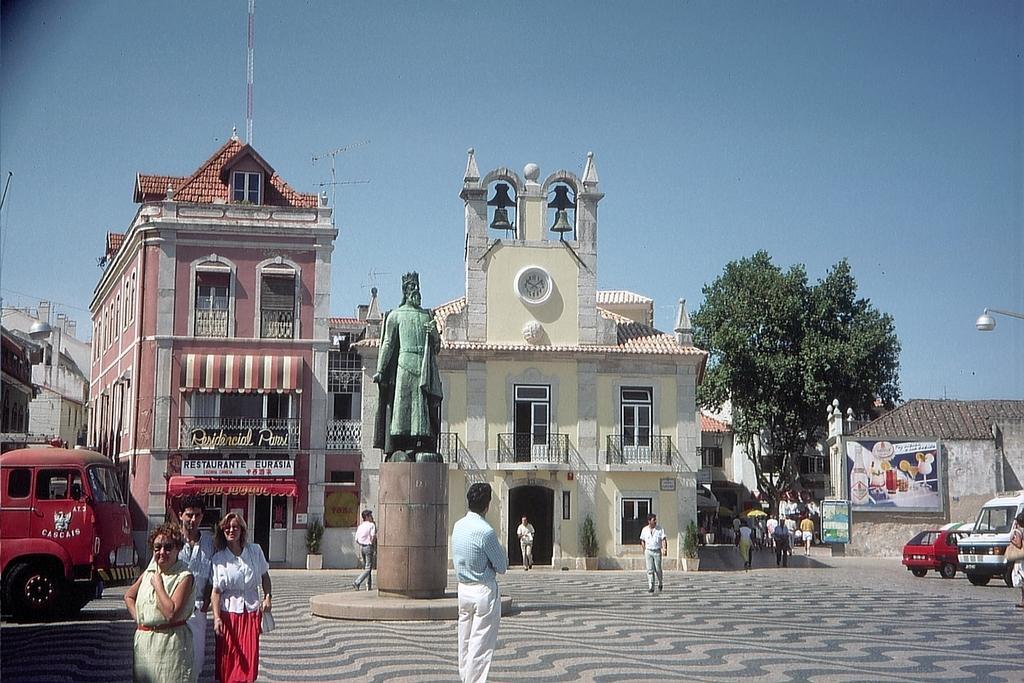Can you describe this image briefly? Here there are buildings with the windows, here there is a try, here there are vehicles, here people are standing, this is sky. 